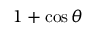Convert formula to latex. <formula><loc_0><loc_0><loc_500><loc_500>1 + \cos \theta</formula> 